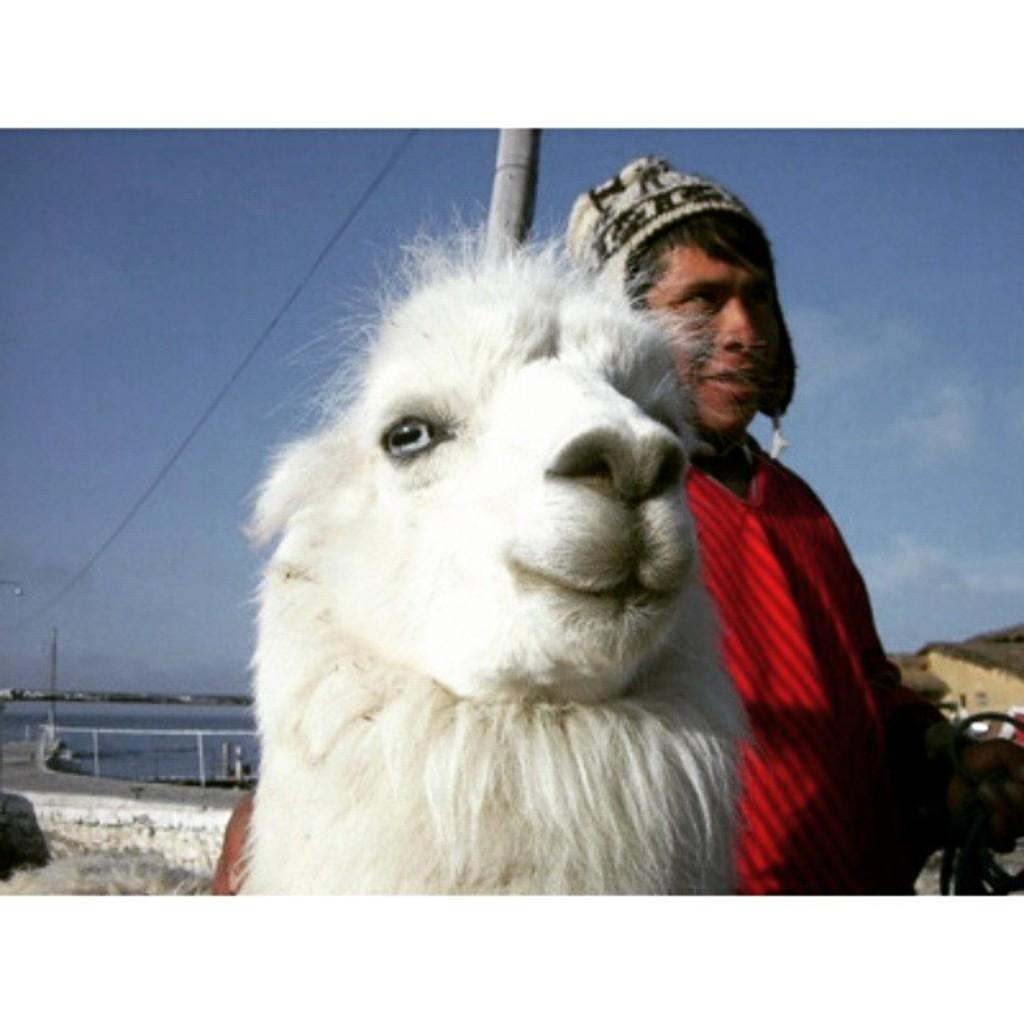What type of animal is in the middle of the image? There is a white color sheep in the image. Who or what is beside the sheep? There is a person beside the sheep. What is the person wearing? The person is wearing a red color sweater. What can be seen at the top of the image? The sky is visible at the top of the image. How many legs does the cart have in the image? There is no cart present in the image, so it is not possible to determine the number of legs it might have. 